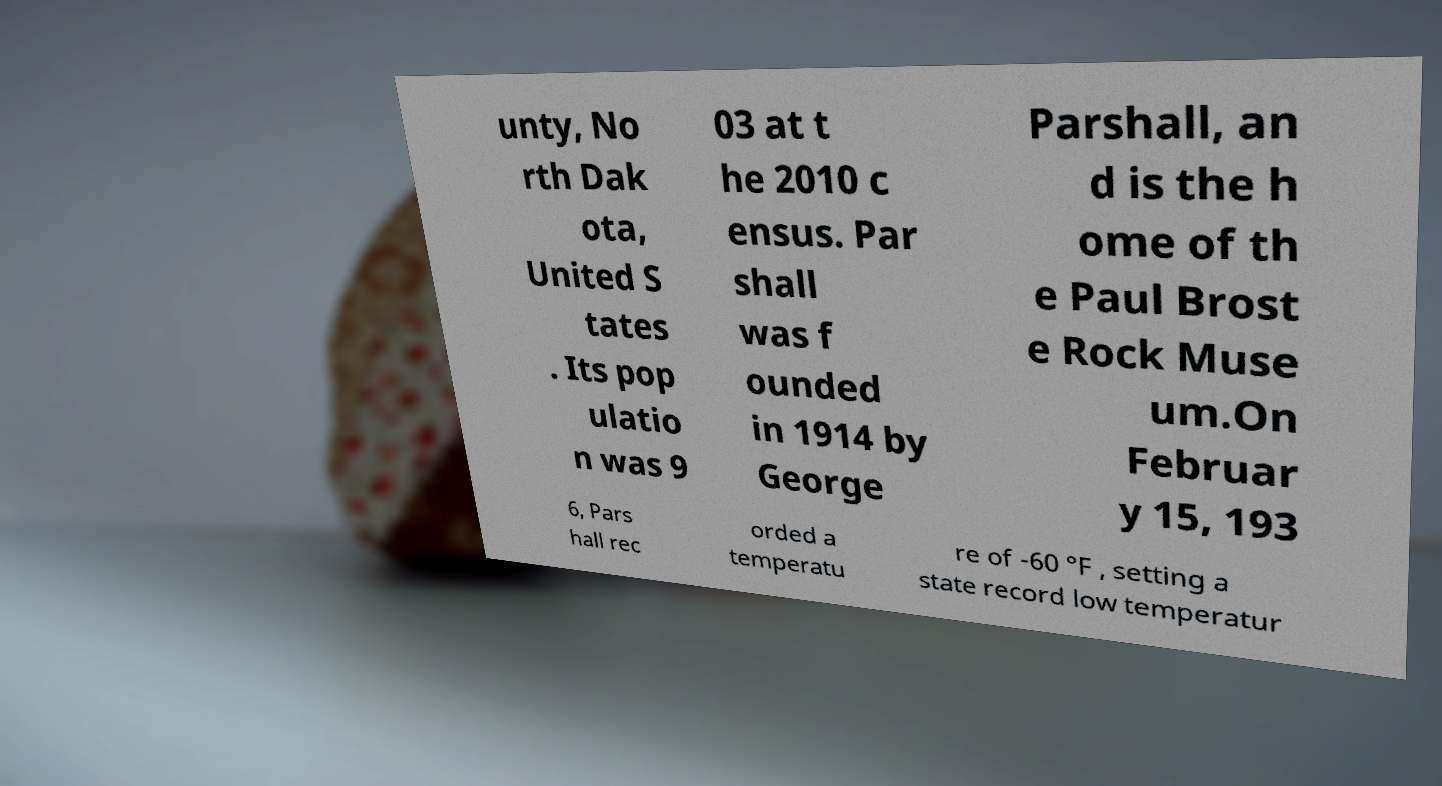Could you extract and type out the text from this image? unty, No rth Dak ota, United S tates . Its pop ulatio n was 9 03 at t he 2010 c ensus. Par shall was f ounded in 1914 by George Parshall, an d is the h ome of th e Paul Brost e Rock Muse um.On Februar y 15, 193 6, Pars hall rec orded a temperatu re of -60 °F , setting a state record low temperatur 